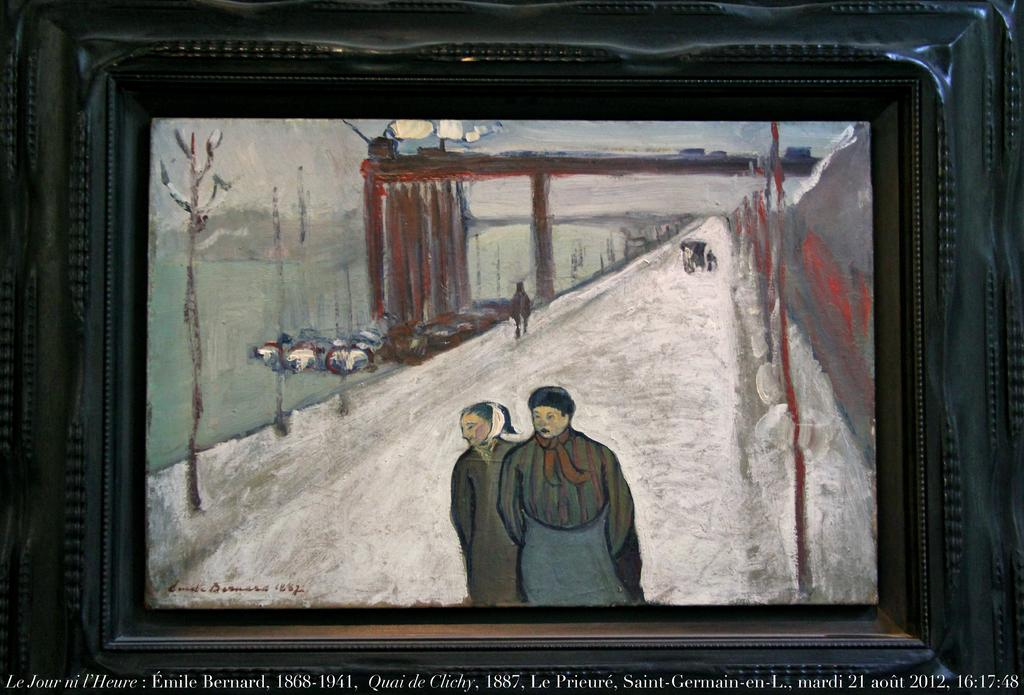<image>
Summarize the visual content of the image. A painting sits above some information stating that Emile Bernard lived from 1868 to 1941. 